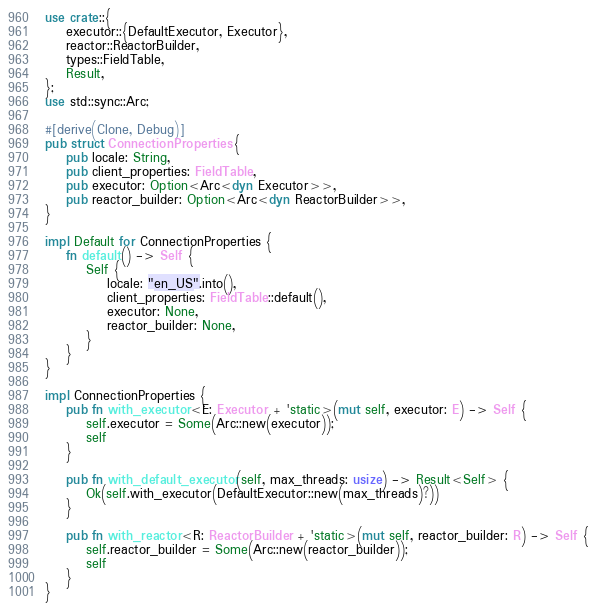Convert code to text. <code><loc_0><loc_0><loc_500><loc_500><_Rust_>use crate::{
    executor::{DefaultExecutor, Executor},
    reactor::ReactorBuilder,
    types::FieldTable,
    Result,
};
use std::sync::Arc;

#[derive(Clone, Debug)]
pub struct ConnectionProperties {
    pub locale: String,
    pub client_properties: FieldTable,
    pub executor: Option<Arc<dyn Executor>>,
    pub reactor_builder: Option<Arc<dyn ReactorBuilder>>,
}

impl Default for ConnectionProperties {
    fn default() -> Self {
        Self {
            locale: "en_US".into(),
            client_properties: FieldTable::default(),
            executor: None,
            reactor_builder: None,
        }
    }
}

impl ConnectionProperties {
    pub fn with_executor<E: Executor + 'static>(mut self, executor: E) -> Self {
        self.executor = Some(Arc::new(executor));
        self
    }

    pub fn with_default_executor(self, max_threads: usize) -> Result<Self> {
        Ok(self.with_executor(DefaultExecutor::new(max_threads)?))
    }

    pub fn with_reactor<R: ReactorBuilder + 'static>(mut self, reactor_builder: R) -> Self {
        self.reactor_builder = Some(Arc::new(reactor_builder));
        self
    }
}
</code> 